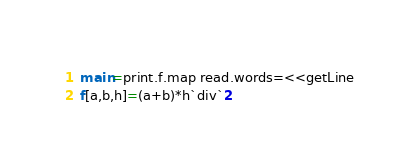<code> <loc_0><loc_0><loc_500><loc_500><_Haskell_>main=print.f.map read.words=<<getLine
f[a,b,h]=(a+b)*h`div`2</code> 